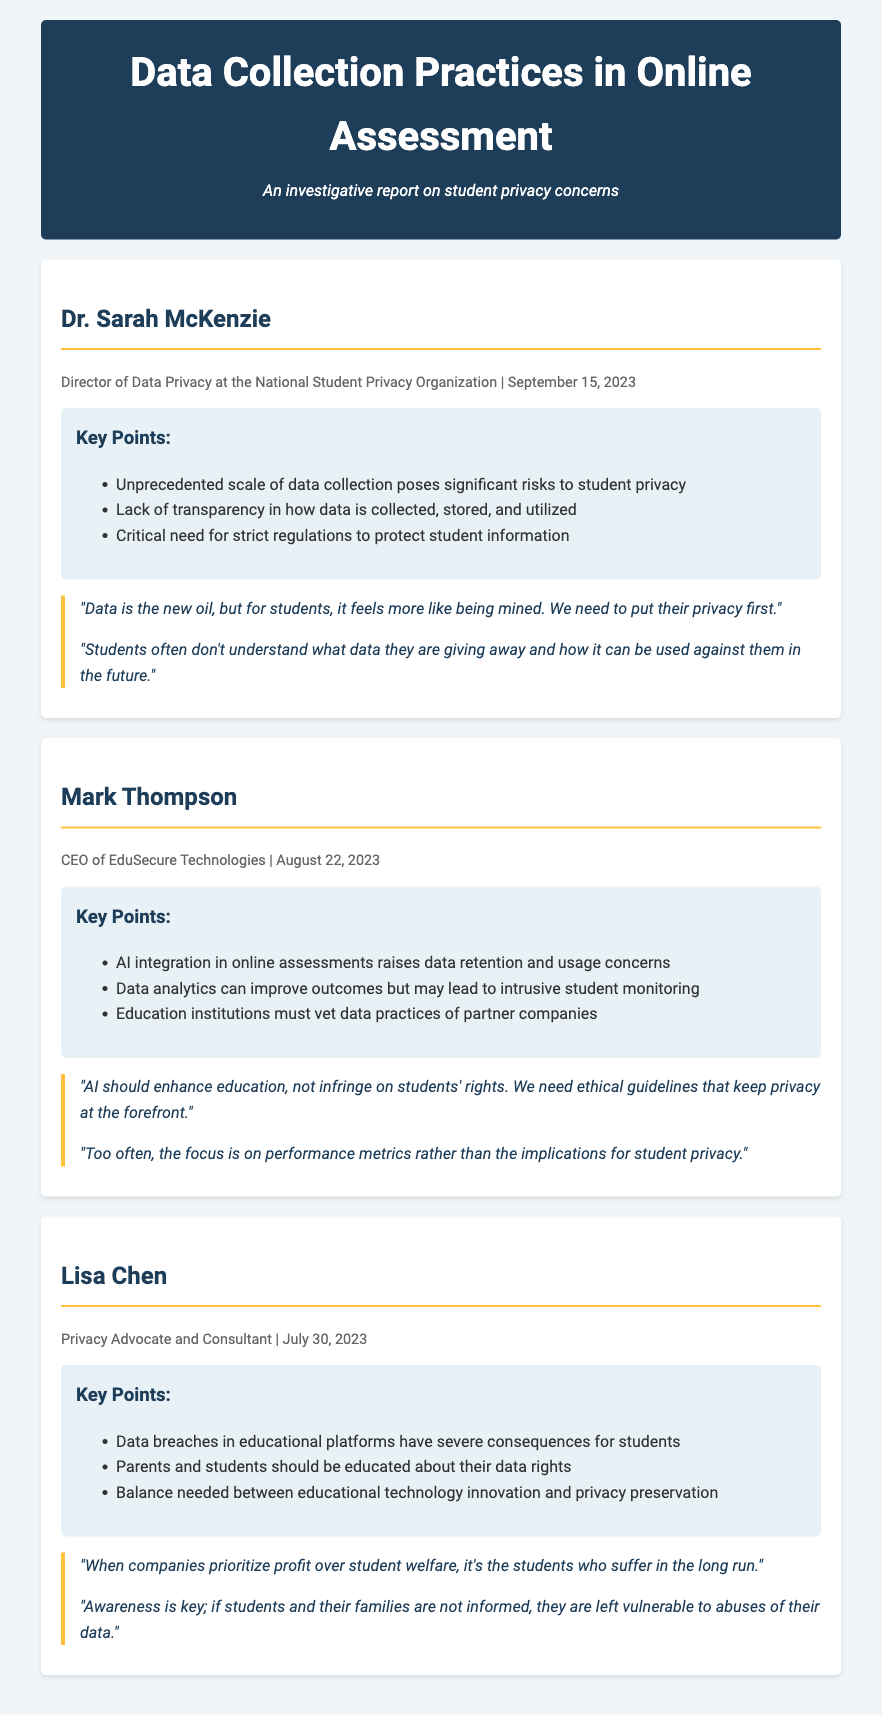What is Dr. Sarah McKenzie's title? Dr. Sarah McKenzie is the Director of Data Privacy at the National Student Privacy Organization.
Answer: Director of Data Privacy On what date did Mark Thompson's interview take place? Mark Thompson's interview occurred on August 22, 2023.
Answer: August 22, 2023 What is a key point mentioned by Lisa Chen regarding data breaches? Lisa Chen mentioned that data breaches in educational platforms have severe consequences for students.
Answer: Severe consequences for students How does Mark Thompson view the integration of AI in education? Mark Thompson believes that AI should enhance education while keeping privacy at the forefront.
Answer: Enhance education, keep privacy What is one of the critical needs highlighted by Dr. Sarah McKenzie? Dr. Sarah McKenzie highlighted a critical need for strict regulations to protect student information.
Answer: Strict regulations What was one of the quotes provided by Lisa Chen? Lisa Chen said, "Awareness is key; if students and their families are not informed, they are left vulnerable to abuses of their data."
Answer: "Awareness is key; if students and their families are not informed, they are left vulnerable to abuses of their data." 